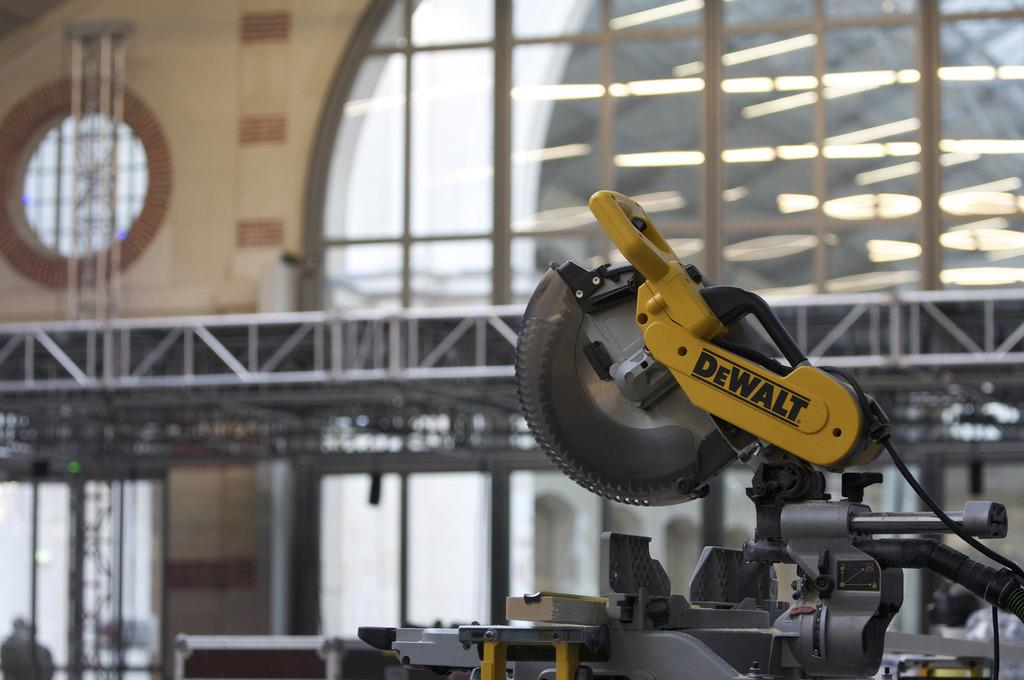<image>
Write a terse but informative summary of the picture. the word dewalt that is on a yellow item 